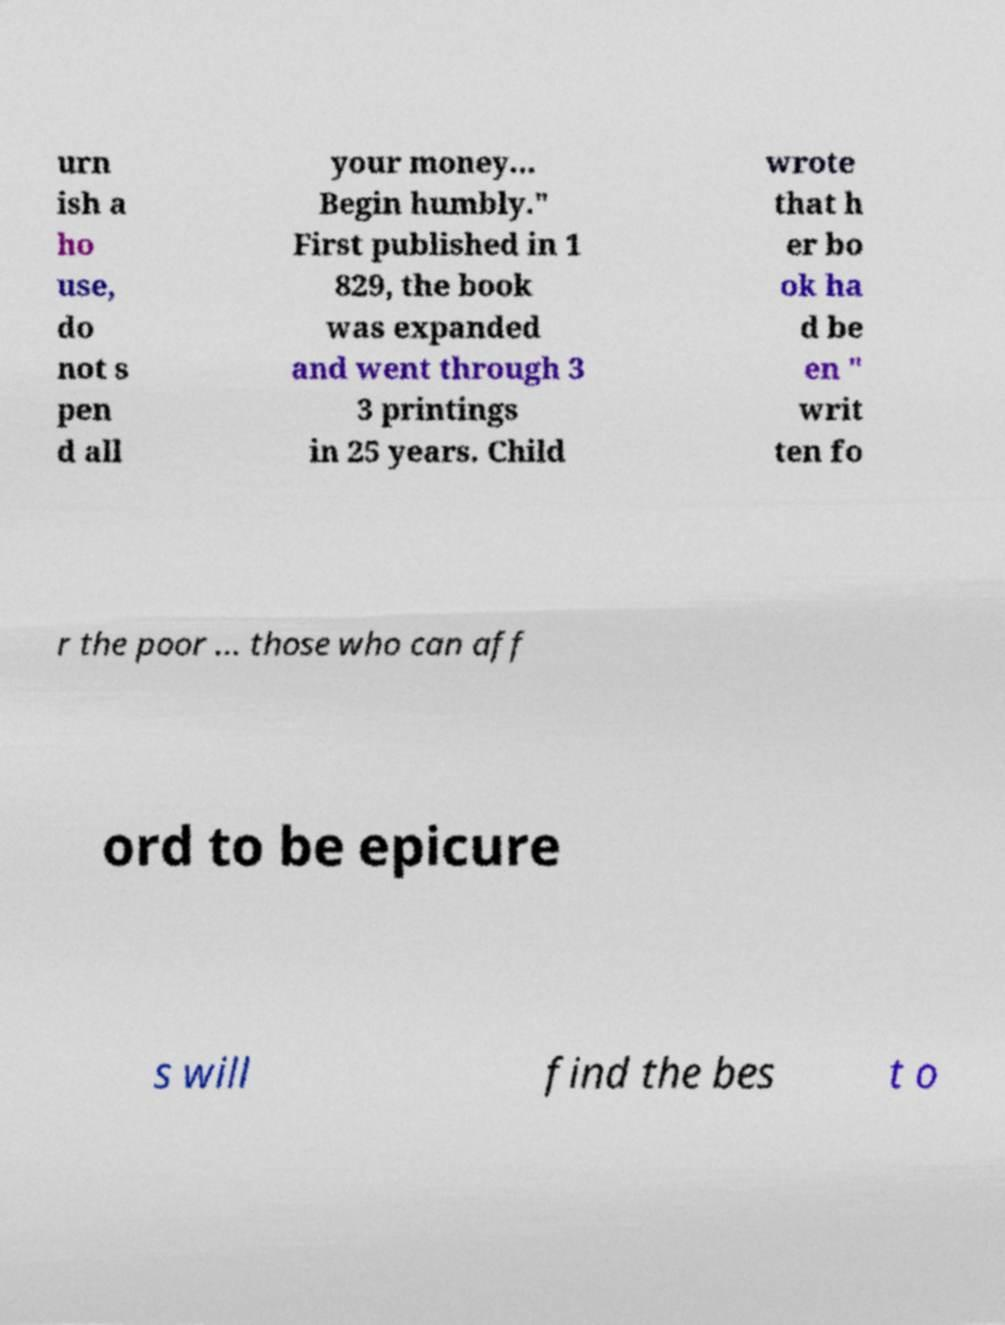I need the written content from this picture converted into text. Can you do that? urn ish a ho use, do not s pen d all your money... Begin humbly." First published in 1 829, the book was expanded and went through 3 3 printings in 25 years. Child wrote that h er bo ok ha d be en " writ ten fo r the poor ... those who can aff ord to be epicure s will find the bes t o 